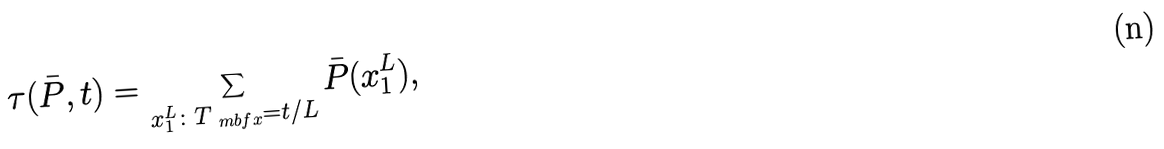<formula> <loc_0><loc_0><loc_500><loc_500>\tau ( \bar { P } , t ) = \sum _ { x _ { 1 } ^ { L } \colon T _ { \ m b f { x } } = t / L } \bar { P } ( x _ { 1 } ^ { L } ) ,</formula> 